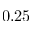Convert formula to latex. <formula><loc_0><loc_0><loc_500><loc_500>0 . 2 5</formula> 